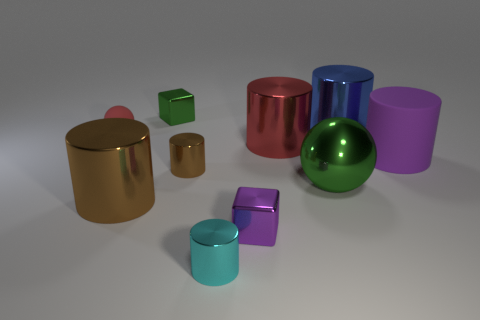What number of large metallic balls are the same color as the matte ball?
Your answer should be compact. 0. What number of small brown objects have the same material as the blue thing?
Offer a terse response. 1. How many things are either big cubes or green metal objects in front of the small brown metal cylinder?
Provide a short and direct response. 1. What is the color of the sphere that is behind the brown metal thing behind the big object that is to the left of the purple shiny thing?
Your answer should be very brief. Red. How big is the green thing in front of the big matte object?
Keep it short and to the point. Large. How many tiny objects are either green matte blocks or cyan metal things?
Provide a succinct answer. 1. What color is the large cylinder that is both behind the purple matte thing and in front of the blue shiny cylinder?
Make the answer very short. Red. Are there any tiny green metal objects of the same shape as the red matte thing?
Your response must be concise. No. What is the material of the red sphere?
Keep it short and to the point. Rubber. Are there any big brown metal cylinders in front of the cyan metal object?
Offer a terse response. No. 